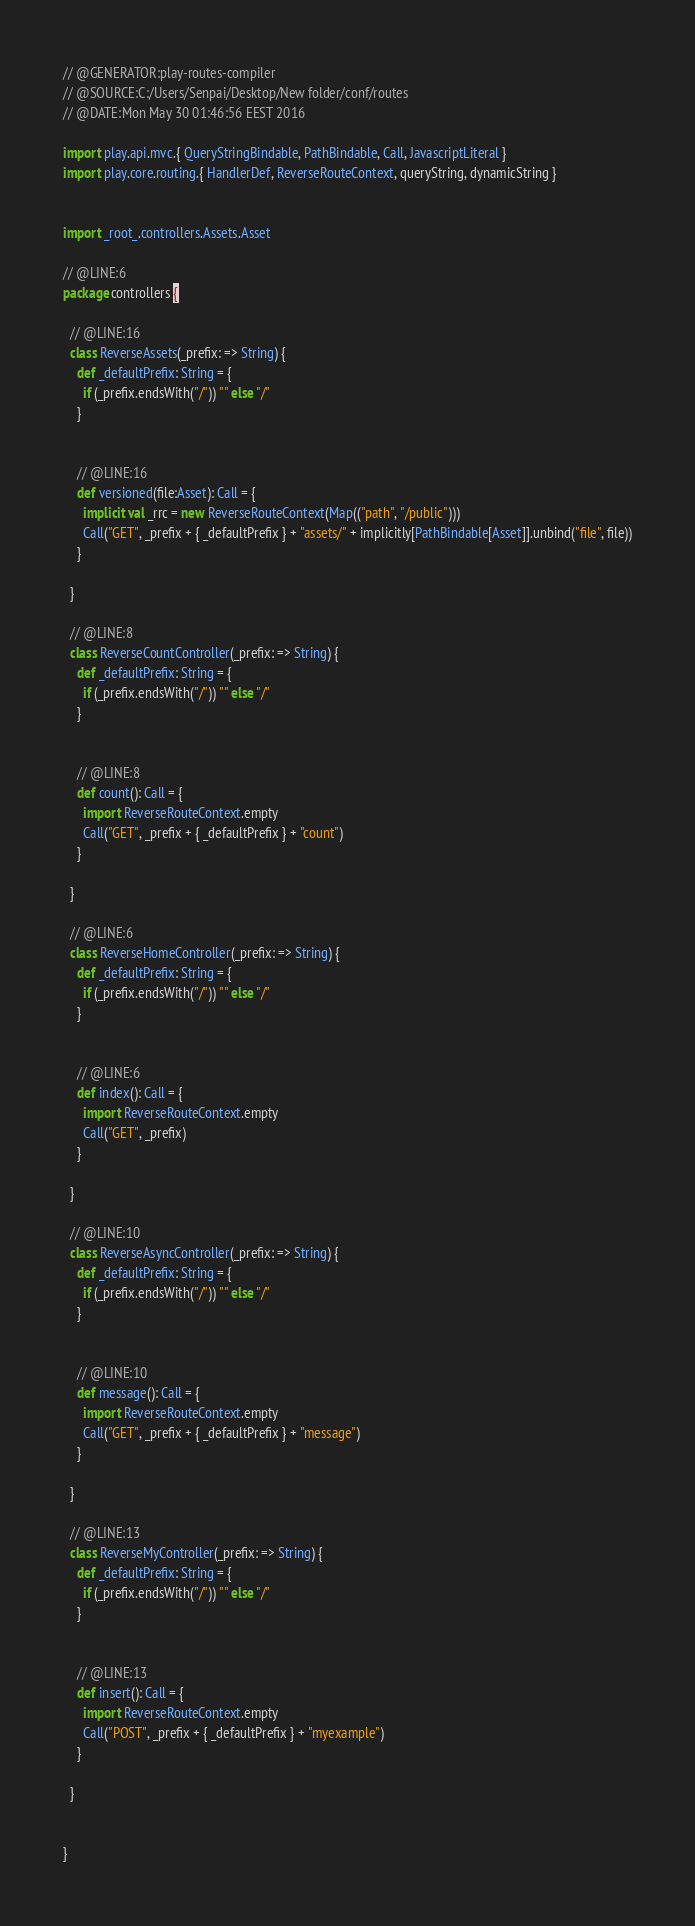<code> <loc_0><loc_0><loc_500><loc_500><_Scala_>
// @GENERATOR:play-routes-compiler
// @SOURCE:C:/Users/Senpai/Desktop/New folder/conf/routes
// @DATE:Mon May 30 01:46:56 EEST 2016

import play.api.mvc.{ QueryStringBindable, PathBindable, Call, JavascriptLiteral }
import play.core.routing.{ HandlerDef, ReverseRouteContext, queryString, dynamicString }


import _root_.controllers.Assets.Asset

// @LINE:6
package controllers {

  // @LINE:16
  class ReverseAssets(_prefix: => String) {
    def _defaultPrefix: String = {
      if (_prefix.endsWith("/")) "" else "/"
    }

  
    // @LINE:16
    def versioned(file:Asset): Call = {
      implicit val _rrc = new ReverseRouteContext(Map(("path", "/public")))
      Call("GET", _prefix + { _defaultPrefix } + "assets/" + implicitly[PathBindable[Asset]].unbind("file", file))
    }
  
  }

  // @LINE:8
  class ReverseCountController(_prefix: => String) {
    def _defaultPrefix: String = {
      if (_prefix.endsWith("/")) "" else "/"
    }

  
    // @LINE:8
    def count(): Call = {
      import ReverseRouteContext.empty
      Call("GET", _prefix + { _defaultPrefix } + "count")
    }
  
  }

  // @LINE:6
  class ReverseHomeController(_prefix: => String) {
    def _defaultPrefix: String = {
      if (_prefix.endsWith("/")) "" else "/"
    }

  
    // @LINE:6
    def index(): Call = {
      import ReverseRouteContext.empty
      Call("GET", _prefix)
    }
  
  }

  // @LINE:10
  class ReverseAsyncController(_prefix: => String) {
    def _defaultPrefix: String = {
      if (_prefix.endsWith("/")) "" else "/"
    }

  
    // @LINE:10
    def message(): Call = {
      import ReverseRouteContext.empty
      Call("GET", _prefix + { _defaultPrefix } + "message")
    }
  
  }

  // @LINE:13
  class ReverseMyController(_prefix: => String) {
    def _defaultPrefix: String = {
      if (_prefix.endsWith("/")) "" else "/"
    }

  
    // @LINE:13
    def insert(): Call = {
      import ReverseRouteContext.empty
      Call("POST", _prefix + { _defaultPrefix } + "myexample")
    }
  
  }


}
</code> 